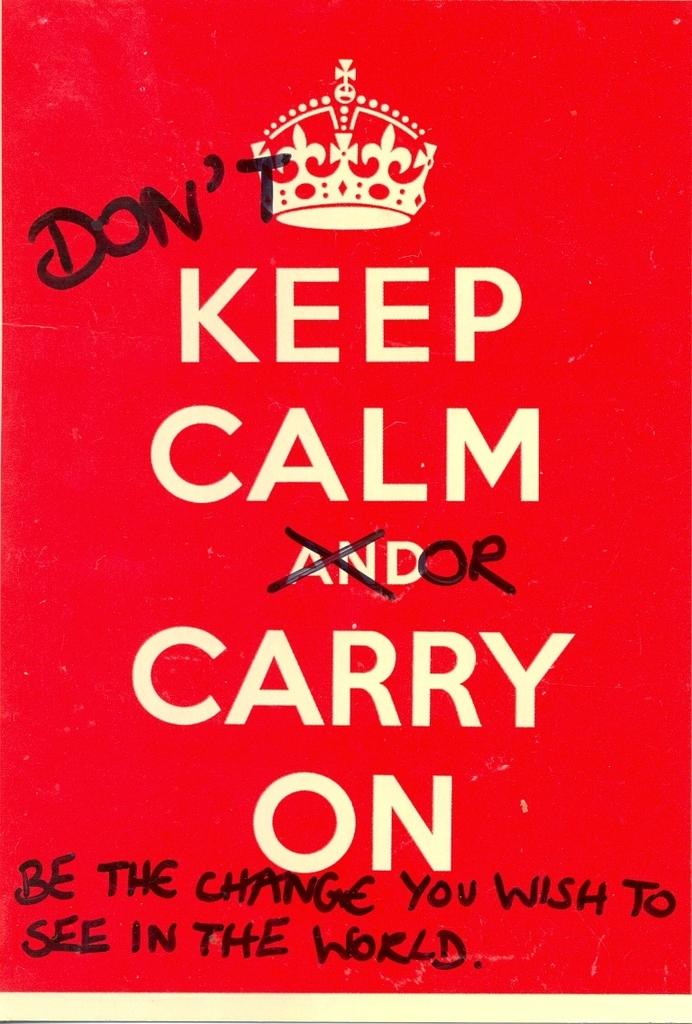What can be found in the image that contains written words? There is text in the image. What type of image is present in the image? There is a crown picture in the image. What is the price of the shop shown in the image? There is no shop present in the image, so it is not possible to determine its price. 